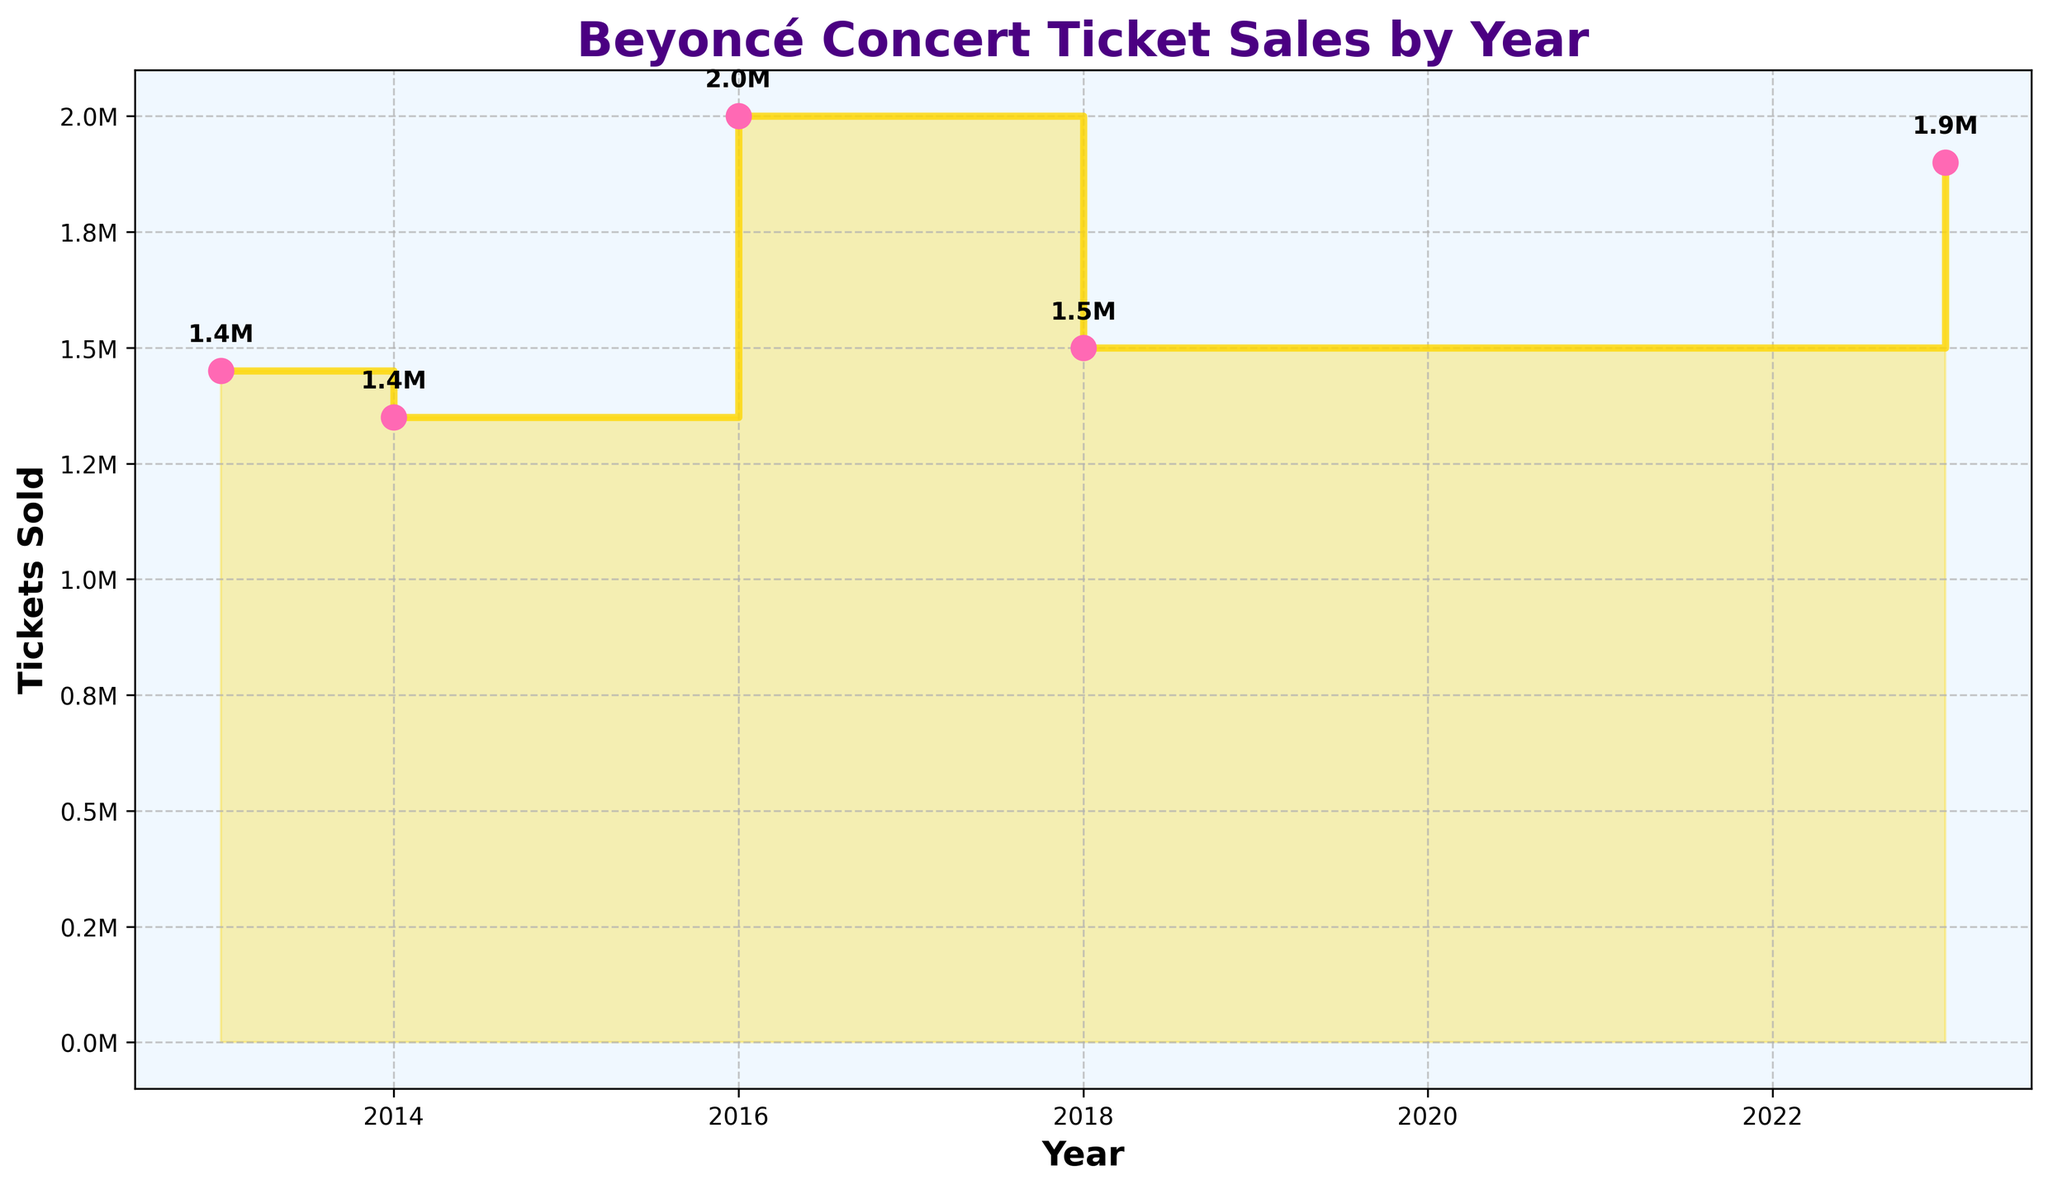What is the title of the plot? The title is usually displayed at the top of the plot. In this plot, it reads "Beyoncé Concert Ticket Sales by Year" in bold and colored in #4B0082 (a dark indigo shade).
Answer: Beyoncé Concert Ticket Sales by Year In which years did Beyoncé sell the highest and the lowest number of tickets in concerts? Identify the highest and lowest points on the y-axis and note the corresponding years on the x-axis. The highest ticket sales occur in 2016, and the lowest occur in 2013.
Answer: Highest: 2016; Lowest: 2013 What is the color of the line used in the stair plot? The stair plot's line color is visible in the figure. It is a gold shade indicated by the color code #FFD700.
Answer: Gold How many tickets were sold in total in 2023? According to the scatter plot and the annotations, the total number of tickets sold in 2023 can be derived by summing the ticket sales for North America and Europe, which is 1.1 million and 0.8 million respectively.
Answer: 1.9 million Compare the ticket sales in 2014 and 2018. Which year had higher sales and by how much? We need to find the total ticket sales for both years from the annotations and compare. 2014 had 1.35 million tickets sold, while 2018 had 1.5 million. Subtracting, we find 2018 had higher sales by 150,000 tickets.
Answer: 2018 by 150,000 tickets What is the color of the scatter plot points marking each year’s total ticket sales? By observing the scatter plot, the color of the data points can be identified. They are a bright pink shade, usually referred to as Hot Pink (#FF69B4).
Answer: Hot Pink What trend can be observed in ticket sales from 2016 to 2023? By examining the stair plot, it's clear that there is a noticeable drop in ticket sales after 2016 up to 2018, followed by a slight increase in 2023. This indicates a period of decline and then recovery in ticket sales.
Answer: Drop and then increase How many years have data points plotted for Beyoncé concert ticket sales? The x-axis lists unique years and visual observation of scatter points, allowing us to count the years with data points. The specific years are 2013, 2014, 2016, 2018, and 2023.
Answer: 5 years If we sum up total ticket sales for North America from all the listed years, what is the result? We need to look at North American ticket sales from different years. Sum 750,000 (2013) + 850,000 (2014) + 900,000 (2018) + 1,100,000 (2023). The result is 3,600,000 tickets.
Answer: 3.6 million tickets Identify which tour sold the most tickets in a single year. Reviewing the annotations and scatter points, The Formation World Tour in 2016 had the highest single-year sales of 2 million tickets.
Answer: The Formation World Tour (2016) 